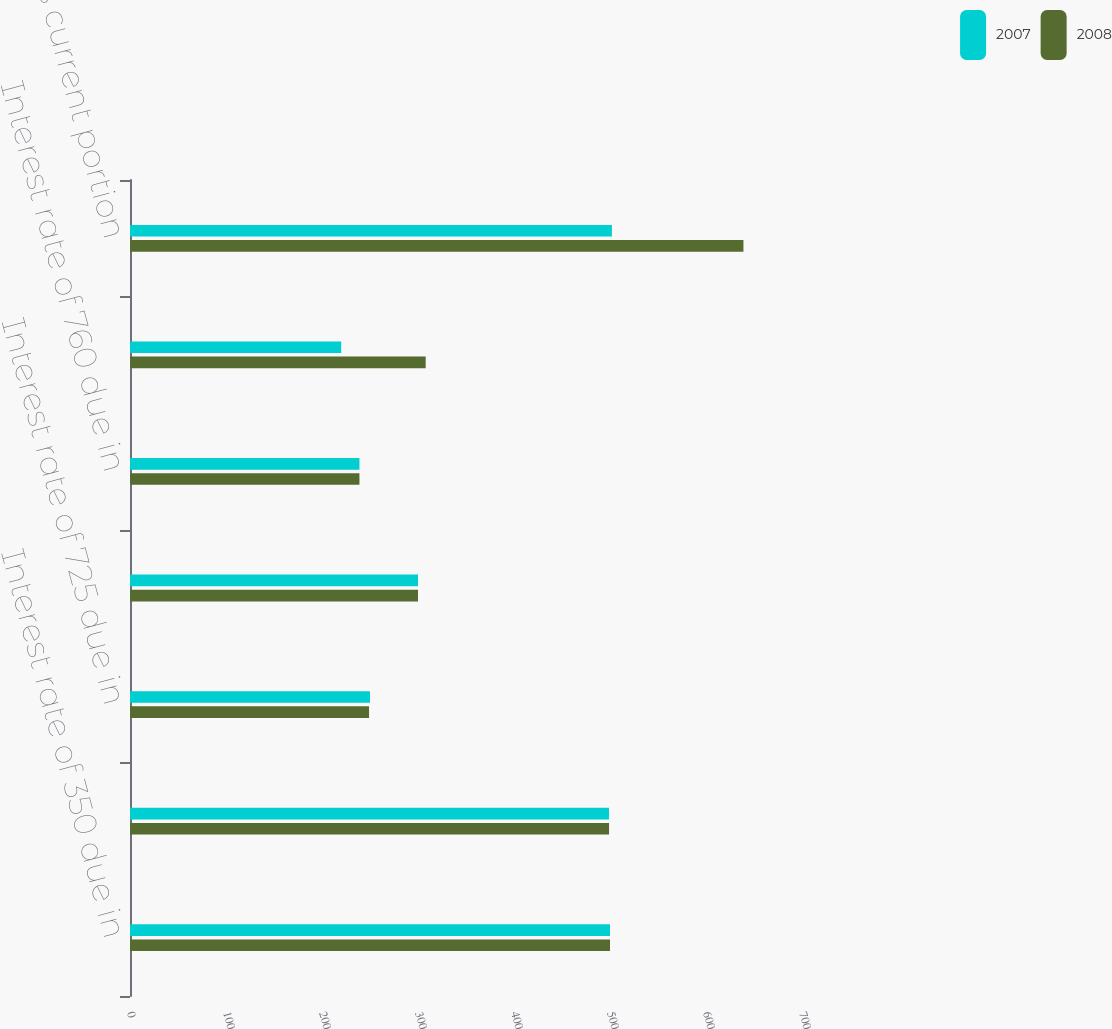<chart> <loc_0><loc_0><loc_500><loc_500><stacked_bar_chart><ecel><fcel>Interest rate of 350 due in<fcel>Interest rate of 550 due in<fcel>Interest rate of 725 due in<fcel>Interest rate of 965 due in<fcel>Interest rate of 760 due in<fcel>Capital lease obligations<fcel>Less current portion<nl><fcel>2007<fcel>500<fcel>499<fcel>250<fcel>300<fcel>239<fcel>220<fcel>502<nl><fcel>2008<fcel>500<fcel>499<fcel>249<fcel>300<fcel>239<fcel>308<fcel>639<nl></chart> 